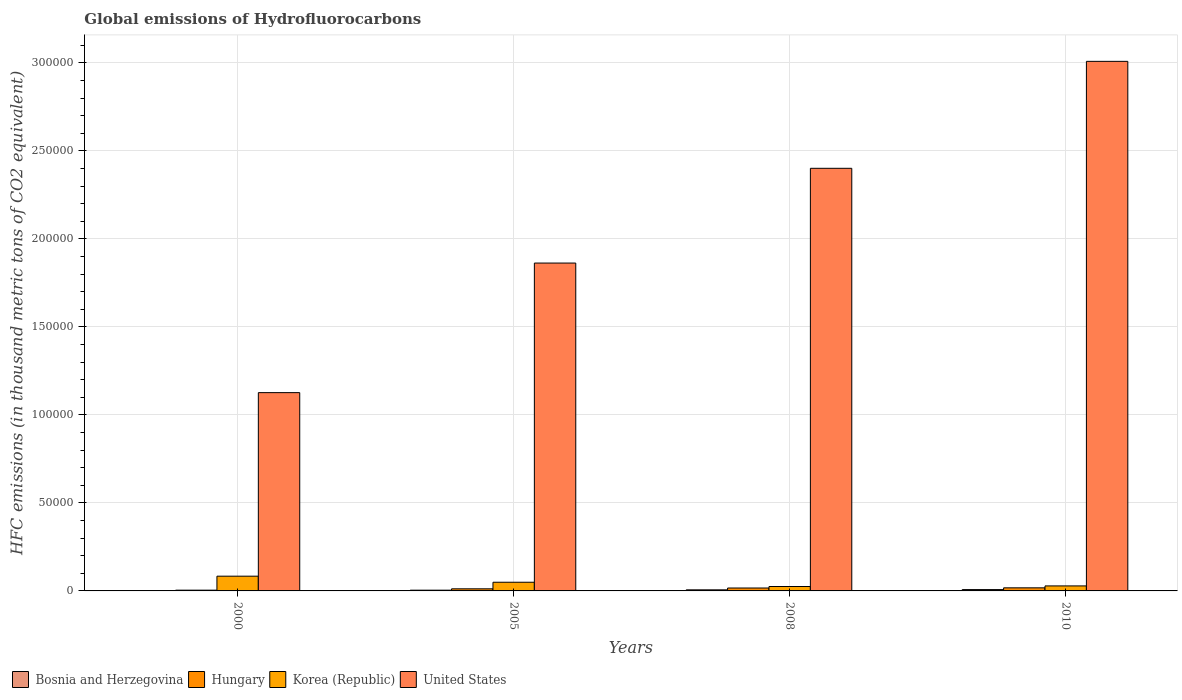How many different coloured bars are there?
Give a very brief answer. 4. Are the number of bars per tick equal to the number of legend labels?
Ensure brevity in your answer.  Yes. Are the number of bars on each tick of the X-axis equal?
Offer a terse response. Yes. How many bars are there on the 2nd tick from the left?
Your response must be concise. 4. What is the label of the 2nd group of bars from the left?
Your answer should be compact. 2005. What is the global emissions of Hydrofluorocarbons in United States in 2008?
Give a very brief answer. 2.40e+05. Across all years, what is the maximum global emissions of Hydrofluorocarbons in Korea (Republic)?
Make the answer very short. 8371.9. Across all years, what is the minimum global emissions of Hydrofluorocarbons in Korea (Republic)?
Offer a very short reply. 2511.2. In which year was the global emissions of Hydrofluorocarbons in Bosnia and Herzegovina maximum?
Keep it short and to the point. 2010. In which year was the global emissions of Hydrofluorocarbons in Korea (Republic) minimum?
Your answer should be very brief. 2008. What is the total global emissions of Hydrofluorocarbons in Korea (Republic) in the graph?
Ensure brevity in your answer.  1.87e+04. What is the difference between the global emissions of Hydrofluorocarbons in Bosnia and Herzegovina in 2005 and that in 2010?
Ensure brevity in your answer.  -332.5. What is the difference between the global emissions of Hydrofluorocarbons in Bosnia and Herzegovina in 2008 and the global emissions of Hydrofluorocarbons in Hungary in 2010?
Offer a terse response. -1131.4. What is the average global emissions of Hydrofluorocarbons in United States per year?
Make the answer very short. 2.10e+05. In the year 2010, what is the difference between the global emissions of Hydrofluorocarbons in Bosnia and Herzegovina and global emissions of Hydrofluorocarbons in Korea (Republic)?
Your answer should be very brief. -2089. What is the ratio of the global emissions of Hydrofluorocarbons in Korea (Republic) in 2005 to that in 2010?
Provide a short and direct response. 1.73. Is the difference between the global emissions of Hydrofluorocarbons in Bosnia and Herzegovina in 2005 and 2008 greater than the difference between the global emissions of Hydrofluorocarbons in Korea (Republic) in 2005 and 2008?
Make the answer very short. No. What is the difference between the highest and the second highest global emissions of Hydrofluorocarbons in Hungary?
Your answer should be very brief. 96.1. What is the difference between the highest and the lowest global emissions of Hydrofluorocarbons in Korea (Republic)?
Offer a very short reply. 5860.7. Is the sum of the global emissions of Hydrofluorocarbons in Korea (Republic) in 2005 and 2010 greater than the maximum global emissions of Hydrofluorocarbons in Bosnia and Herzegovina across all years?
Offer a very short reply. Yes. Is it the case that in every year, the sum of the global emissions of Hydrofluorocarbons in Bosnia and Herzegovina and global emissions of Hydrofluorocarbons in United States is greater than the sum of global emissions of Hydrofluorocarbons in Korea (Republic) and global emissions of Hydrofluorocarbons in Hungary?
Provide a succinct answer. Yes. What does the 2nd bar from the left in 2000 represents?
Keep it short and to the point. Hungary. What does the 3rd bar from the right in 2005 represents?
Your response must be concise. Hungary. Is it the case that in every year, the sum of the global emissions of Hydrofluorocarbons in Hungary and global emissions of Hydrofluorocarbons in Korea (Republic) is greater than the global emissions of Hydrofluorocarbons in Bosnia and Herzegovina?
Make the answer very short. Yes. What is the difference between two consecutive major ticks on the Y-axis?
Ensure brevity in your answer.  5.00e+04. Are the values on the major ticks of Y-axis written in scientific E-notation?
Your answer should be compact. No. Does the graph contain any zero values?
Ensure brevity in your answer.  No. Does the graph contain grids?
Offer a very short reply. Yes. What is the title of the graph?
Offer a very short reply. Global emissions of Hydrofluorocarbons. Does "Upper middle income" appear as one of the legend labels in the graph?
Make the answer very short. No. What is the label or title of the X-axis?
Your response must be concise. Years. What is the label or title of the Y-axis?
Your answer should be compact. HFC emissions (in thousand metric tons of CO2 equivalent). What is the HFC emissions (in thousand metric tons of CO2 equivalent) in Bosnia and Herzegovina in 2000?
Offer a very short reply. 79.8. What is the HFC emissions (in thousand metric tons of CO2 equivalent) of Hungary in 2000?
Provide a succinct answer. 428.2. What is the HFC emissions (in thousand metric tons of CO2 equivalent) in Korea (Republic) in 2000?
Your answer should be compact. 8371.9. What is the HFC emissions (in thousand metric tons of CO2 equivalent) in United States in 2000?
Provide a succinct answer. 1.13e+05. What is the HFC emissions (in thousand metric tons of CO2 equivalent) in Bosnia and Herzegovina in 2005?
Provide a succinct answer. 422.5. What is the HFC emissions (in thousand metric tons of CO2 equivalent) in Hungary in 2005?
Provide a succinct answer. 1191.4. What is the HFC emissions (in thousand metric tons of CO2 equivalent) in Korea (Republic) in 2005?
Your answer should be very brief. 4933.9. What is the HFC emissions (in thousand metric tons of CO2 equivalent) in United States in 2005?
Your answer should be very brief. 1.86e+05. What is the HFC emissions (in thousand metric tons of CO2 equivalent) of Bosnia and Herzegovina in 2008?
Your answer should be very brief. 617.6. What is the HFC emissions (in thousand metric tons of CO2 equivalent) of Hungary in 2008?
Give a very brief answer. 1652.9. What is the HFC emissions (in thousand metric tons of CO2 equivalent) of Korea (Republic) in 2008?
Provide a short and direct response. 2511.2. What is the HFC emissions (in thousand metric tons of CO2 equivalent) in United States in 2008?
Provide a short and direct response. 2.40e+05. What is the HFC emissions (in thousand metric tons of CO2 equivalent) of Bosnia and Herzegovina in 2010?
Your response must be concise. 755. What is the HFC emissions (in thousand metric tons of CO2 equivalent) of Hungary in 2010?
Your answer should be compact. 1749. What is the HFC emissions (in thousand metric tons of CO2 equivalent) in Korea (Republic) in 2010?
Your response must be concise. 2844. What is the HFC emissions (in thousand metric tons of CO2 equivalent) of United States in 2010?
Offer a terse response. 3.01e+05. Across all years, what is the maximum HFC emissions (in thousand metric tons of CO2 equivalent) of Bosnia and Herzegovina?
Provide a succinct answer. 755. Across all years, what is the maximum HFC emissions (in thousand metric tons of CO2 equivalent) of Hungary?
Offer a very short reply. 1749. Across all years, what is the maximum HFC emissions (in thousand metric tons of CO2 equivalent) in Korea (Republic)?
Make the answer very short. 8371.9. Across all years, what is the maximum HFC emissions (in thousand metric tons of CO2 equivalent) in United States?
Offer a very short reply. 3.01e+05. Across all years, what is the minimum HFC emissions (in thousand metric tons of CO2 equivalent) of Bosnia and Herzegovina?
Provide a short and direct response. 79.8. Across all years, what is the minimum HFC emissions (in thousand metric tons of CO2 equivalent) in Hungary?
Provide a succinct answer. 428.2. Across all years, what is the minimum HFC emissions (in thousand metric tons of CO2 equivalent) of Korea (Republic)?
Ensure brevity in your answer.  2511.2. Across all years, what is the minimum HFC emissions (in thousand metric tons of CO2 equivalent) in United States?
Offer a terse response. 1.13e+05. What is the total HFC emissions (in thousand metric tons of CO2 equivalent) of Bosnia and Herzegovina in the graph?
Give a very brief answer. 1874.9. What is the total HFC emissions (in thousand metric tons of CO2 equivalent) of Hungary in the graph?
Provide a short and direct response. 5021.5. What is the total HFC emissions (in thousand metric tons of CO2 equivalent) in Korea (Republic) in the graph?
Offer a terse response. 1.87e+04. What is the total HFC emissions (in thousand metric tons of CO2 equivalent) of United States in the graph?
Provide a succinct answer. 8.40e+05. What is the difference between the HFC emissions (in thousand metric tons of CO2 equivalent) of Bosnia and Herzegovina in 2000 and that in 2005?
Keep it short and to the point. -342.7. What is the difference between the HFC emissions (in thousand metric tons of CO2 equivalent) in Hungary in 2000 and that in 2005?
Your response must be concise. -763.2. What is the difference between the HFC emissions (in thousand metric tons of CO2 equivalent) of Korea (Republic) in 2000 and that in 2005?
Make the answer very short. 3438. What is the difference between the HFC emissions (in thousand metric tons of CO2 equivalent) in United States in 2000 and that in 2005?
Ensure brevity in your answer.  -7.36e+04. What is the difference between the HFC emissions (in thousand metric tons of CO2 equivalent) of Bosnia and Herzegovina in 2000 and that in 2008?
Provide a short and direct response. -537.8. What is the difference between the HFC emissions (in thousand metric tons of CO2 equivalent) in Hungary in 2000 and that in 2008?
Provide a short and direct response. -1224.7. What is the difference between the HFC emissions (in thousand metric tons of CO2 equivalent) of Korea (Republic) in 2000 and that in 2008?
Keep it short and to the point. 5860.7. What is the difference between the HFC emissions (in thousand metric tons of CO2 equivalent) in United States in 2000 and that in 2008?
Give a very brief answer. -1.27e+05. What is the difference between the HFC emissions (in thousand metric tons of CO2 equivalent) of Bosnia and Herzegovina in 2000 and that in 2010?
Your answer should be compact. -675.2. What is the difference between the HFC emissions (in thousand metric tons of CO2 equivalent) of Hungary in 2000 and that in 2010?
Offer a very short reply. -1320.8. What is the difference between the HFC emissions (in thousand metric tons of CO2 equivalent) of Korea (Republic) in 2000 and that in 2010?
Ensure brevity in your answer.  5527.9. What is the difference between the HFC emissions (in thousand metric tons of CO2 equivalent) of United States in 2000 and that in 2010?
Offer a very short reply. -1.88e+05. What is the difference between the HFC emissions (in thousand metric tons of CO2 equivalent) in Bosnia and Herzegovina in 2005 and that in 2008?
Provide a succinct answer. -195.1. What is the difference between the HFC emissions (in thousand metric tons of CO2 equivalent) in Hungary in 2005 and that in 2008?
Offer a very short reply. -461.5. What is the difference between the HFC emissions (in thousand metric tons of CO2 equivalent) of Korea (Republic) in 2005 and that in 2008?
Provide a succinct answer. 2422.7. What is the difference between the HFC emissions (in thousand metric tons of CO2 equivalent) of United States in 2005 and that in 2008?
Give a very brief answer. -5.38e+04. What is the difference between the HFC emissions (in thousand metric tons of CO2 equivalent) in Bosnia and Herzegovina in 2005 and that in 2010?
Provide a short and direct response. -332.5. What is the difference between the HFC emissions (in thousand metric tons of CO2 equivalent) in Hungary in 2005 and that in 2010?
Your answer should be very brief. -557.6. What is the difference between the HFC emissions (in thousand metric tons of CO2 equivalent) of Korea (Republic) in 2005 and that in 2010?
Provide a succinct answer. 2089.9. What is the difference between the HFC emissions (in thousand metric tons of CO2 equivalent) of United States in 2005 and that in 2010?
Provide a succinct answer. -1.15e+05. What is the difference between the HFC emissions (in thousand metric tons of CO2 equivalent) in Bosnia and Herzegovina in 2008 and that in 2010?
Offer a very short reply. -137.4. What is the difference between the HFC emissions (in thousand metric tons of CO2 equivalent) of Hungary in 2008 and that in 2010?
Your answer should be very brief. -96.1. What is the difference between the HFC emissions (in thousand metric tons of CO2 equivalent) of Korea (Republic) in 2008 and that in 2010?
Your answer should be very brief. -332.8. What is the difference between the HFC emissions (in thousand metric tons of CO2 equivalent) in United States in 2008 and that in 2010?
Your response must be concise. -6.08e+04. What is the difference between the HFC emissions (in thousand metric tons of CO2 equivalent) in Bosnia and Herzegovina in 2000 and the HFC emissions (in thousand metric tons of CO2 equivalent) in Hungary in 2005?
Offer a terse response. -1111.6. What is the difference between the HFC emissions (in thousand metric tons of CO2 equivalent) of Bosnia and Herzegovina in 2000 and the HFC emissions (in thousand metric tons of CO2 equivalent) of Korea (Republic) in 2005?
Provide a short and direct response. -4854.1. What is the difference between the HFC emissions (in thousand metric tons of CO2 equivalent) in Bosnia and Herzegovina in 2000 and the HFC emissions (in thousand metric tons of CO2 equivalent) in United States in 2005?
Your answer should be compact. -1.86e+05. What is the difference between the HFC emissions (in thousand metric tons of CO2 equivalent) of Hungary in 2000 and the HFC emissions (in thousand metric tons of CO2 equivalent) of Korea (Republic) in 2005?
Provide a short and direct response. -4505.7. What is the difference between the HFC emissions (in thousand metric tons of CO2 equivalent) of Hungary in 2000 and the HFC emissions (in thousand metric tons of CO2 equivalent) of United States in 2005?
Ensure brevity in your answer.  -1.86e+05. What is the difference between the HFC emissions (in thousand metric tons of CO2 equivalent) in Korea (Republic) in 2000 and the HFC emissions (in thousand metric tons of CO2 equivalent) in United States in 2005?
Ensure brevity in your answer.  -1.78e+05. What is the difference between the HFC emissions (in thousand metric tons of CO2 equivalent) of Bosnia and Herzegovina in 2000 and the HFC emissions (in thousand metric tons of CO2 equivalent) of Hungary in 2008?
Ensure brevity in your answer.  -1573.1. What is the difference between the HFC emissions (in thousand metric tons of CO2 equivalent) in Bosnia and Herzegovina in 2000 and the HFC emissions (in thousand metric tons of CO2 equivalent) in Korea (Republic) in 2008?
Your answer should be compact. -2431.4. What is the difference between the HFC emissions (in thousand metric tons of CO2 equivalent) in Bosnia and Herzegovina in 2000 and the HFC emissions (in thousand metric tons of CO2 equivalent) in United States in 2008?
Ensure brevity in your answer.  -2.40e+05. What is the difference between the HFC emissions (in thousand metric tons of CO2 equivalent) of Hungary in 2000 and the HFC emissions (in thousand metric tons of CO2 equivalent) of Korea (Republic) in 2008?
Give a very brief answer. -2083. What is the difference between the HFC emissions (in thousand metric tons of CO2 equivalent) of Hungary in 2000 and the HFC emissions (in thousand metric tons of CO2 equivalent) of United States in 2008?
Keep it short and to the point. -2.40e+05. What is the difference between the HFC emissions (in thousand metric tons of CO2 equivalent) of Korea (Republic) in 2000 and the HFC emissions (in thousand metric tons of CO2 equivalent) of United States in 2008?
Provide a succinct answer. -2.32e+05. What is the difference between the HFC emissions (in thousand metric tons of CO2 equivalent) in Bosnia and Herzegovina in 2000 and the HFC emissions (in thousand metric tons of CO2 equivalent) in Hungary in 2010?
Ensure brevity in your answer.  -1669.2. What is the difference between the HFC emissions (in thousand metric tons of CO2 equivalent) of Bosnia and Herzegovina in 2000 and the HFC emissions (in thousand metric tons of CO2 equivalent) of Korea (Republic) in 2010?
Provide a short and direct response. -2764.2. What is the difference between the HFC emissions (in thousand metric tons of CO2 equivalent) in Bosnia and Herzegovina in 2000 and the HFC emissions (in thousand metric tons of CO2 equivalent) in United States in 2010?
Ensure brevity in your answer.  -3.01e+05. What is the difference between the HFC emissions (in thousand metric tons of CO2 equivalent) of Hungary in 2000 and the HFC emissions (in thousand metric tons of CO2 equivalent) of Korea (Republic) in 2010?
Offer a terse response. -2415.8. What is the difference between the HFC emissions (in thousand metric tons of CO2 equivalent) of Hungary in 2000 and the HFC emissions (in thousand metric tons of CO2 equivalent) of United States in 2010?
Provide a short and direct response. -3.00e+05. What is the difference between the HFC emissions (in thousand metric tons of CO2 equivalent) in Korea (Republic) in 2000 and the HFC emissions (in thousand metric tons of CO2 equivalent) in United States in 2010?
Offer a very short reply. -2.93e+05. What is the difference between the HFC emissions (in thousand metric tons of CO2 equivalent) of Bosnia and Herzegovina in 2005 and the HFC emissions (in thousand metric tons of CO2 equivalent) of Hungary in 2008?
Your response must be concise. -1230.4. What is the difference between the HFC emissions (in thousand metric tons of CO2 equivalent) of Bosnia and Herzegovina in 2005 and the HFC emissions (in thousand metric tons of CO2 equivalent) of Korea (Republic) in 2008?
Offer a very short reply. -2088.7. What is the difference between the HFC emissions (in thousand metric tons of CO2 equivalent) in Bosnia and Herzegovina in 2005 and the HFC emissions (in thousand metric tons of CO2 equivalent) in United States in 2008?
Offer a very short reply. -2.40e+05. What is the difference between the HFC emissions (in thousand metric tons of CO2 equivalent) in Hungary in 2005 and the HFC emissions (in thousand metric tons of CO2 equivalent) in Korea (Republic) in 2008?
Give a very brief answer. -1319.8. What is the difference between the HFC emissions (in thousand metric tons of CO2 equivalent) of Hungary in 2005 and the HFC emissions (in thousand metric tons of CO2 equivalent) of United States in 2008?
Give a very brief answer. -2.39e+05. What is the difference between the HFC emissions (in thousand metric tons of CO2 equivalent) of Korea (Republic) in 2005 and the HFC emissions (in thousand metric tons of CO2 equivalent) of United States in 2008?
Offer a very short reply. -2.35e+05. What is the difference between the HFC emissions (in thousand metric tons of CO2 equivalent) of Bosnia and Herzegovina in 2005 and the HFC emissions (in thousand metric tons of CO2 equivalent) of Hungary in 2010?
Ensure brevity in your answer.  -1326.5. What is the difference between the HFC emissions (in thousand metric tons of CO2 equivalent) of Bosnia and Herzegovina in 2005 and the HFC emissions (in thousand metric tons of CO2 equivalent) of Korea (Republic) in 2010?
Offer a very short reply. -2421.5. What is the difference between the HFC emissions (in thousand metric tons of CO2 equivalent) in Bosnia and Herzegovina in 2005 and the HFC emissions (in thousand metric tons of CO2 equivalent) in United States in 2010?
Provide a succinct answer. -3.00e+05. What is the difference between the HFC emissions (in thousand metric tons of CO2 equivalent) in Hungary in 2005 and the HFC emissions (in thousand metric tons of CO2 equivalent) in Korea (Republic) in 2010?
Your answer should be compact. -1652.6. What is the difference between the HFC emissions (in thousand metric tons of CO2 equivalent) in Hungary in 2005 and the HFC emissions (in thousand metric tons of CO2 equivalent) in United States in 2010?
Offer a terse response. -3.00e+05. What is the difference between the HFC emissions (in thousand metric tons of CO2 equivalent) of Korea (Republic) in 2005 and the HFC emissions (in thousand metric tons of CO2 equivalent) of United States in 2010?
Offer a very short reply. -2.96e+05. What is the difference between the HFC emissions (in thousand metric tons of CO2 equivalent) of Bosnia and Herzegovina in 2008 and the HFC emissions (in thousand metric tons of CO2 equivalent) of Hungary in 2010?
Provide a succinct answer. -1131.4. What is the difference between the HFC emissions (in thousand metric tons of CO2 equivalent) of Bosnia and Herzegovina in 2008 and the HFC emissions (in thousand metric tons of CO2 equivalent) of Korea (Republic) in 2010?
Provide a short and direct response. -2226.4. What is the difference between the HFC emissions (in thousand metric tons of CO2 equivalent) in Bosnia and Herzegovina in 2008 and the HFC emissions (in thousand metric tons of CO2 equivalent) in United States in 2010?
Make the answer very short. -3.00e+05. What is the difference between the HFC emissions (in thousand metric tons of CO2 equivalent) of Hungary in 2008 and the HFC emissions (in thousand metric tons of CO2 equivalent) of Korea (Republic) in 2010?
Your answer should be compact. -1191.1. What is the difference between the HFC emissions (in thousand metric tons of CO2 equivalent) in Hungary in 2008 and the HFC emissions (in thousand metric tons of CO2 equivalent) in United States in 2010?
Provide a short and direct response. -2.99e+05. What is the difference between the HFC emissions (in thousand metric tons of CO2 equivalent) in Korea (Republic) in 2008 and the HFC emissions (in thousand metric tons of CO2 equivalent) in United States in 2010?
Make the answer very short. -2.98e+05. What is the average HFC emissions (in thousand metric tons of CO2 equivalent) in Bosnia and Herzegovina per year?
Your answer should be compact. 468.73. What is the average HFC emissions (in thousand metric tons of CO2 equivalent) of Hungary per year?
Your answer should be compact. 1255.38. What is the average HFC emissions (in thousand metric tons of CO2 equivalent) in Korea (Republic) per year?
Provide a succinct answer. 4665.25. What is the average HFC emissions (in thousand metric tons of CO2 equivalent) in United States per year?
Offer a very short reply. 2.10e+05. In the year 2000, what is the difference between the HFC emissions (in thousand metric tons of CO2 equivalent) in Bosnia and Herzegovina and HFC emissions (in thousand metric tons of CO2 equivalent) in Hungary?
Give a very brief answer. -348.4. In the year 2000, what is the difference between the HFC emissions (in thousand metric tons of CO2 equivalent) of Bosnia and Herzegovina and HFC emissions (in thousand metric tons of CO2 equivalent) of Korea (Republic)?
Give a very brief answer. -8292.1. In the year 2000, what is the difference between the HFC emissions (in thousand metric tons of CO2 equivalent) of Bosnia and Herzegovina and HFC emissions (in thousand metric tons of CO2 equivalent) of United States?
Make the answer very short. -1.13e+05. In the year 2000, what is the difference between the HFC emissions (in thousand metric tons of CO2 equivalent) in Hungary and HFC emissions (in thousand metric tons of CO2 equivalent) in Korea (Republic)?
Offer a very short reply. -7943.7. In the year 2000, what is the difference between the HFC emissions (in thousand metric tons of CO2 equivalent) of Hungary and HFC emissions (in thousand metric tons of CO2 equivalent) of United States?
Your answer should be compact. -1.12e+05. In the year 2000, what is the difference between the HFC emissions (in thousand metric tons of CO2 equivalent) of Korea (Republic) and HFC emissions (in thousand metric tons of CO2 equivalent) of United States?
Your response must be concise. -1.04e+05. In the year 2005, what is the difference between the HFC emissions (in thousand metric tons of CO2 equivalent) of Bosnia and Herzegovina and HFC emissions (in thousand metric tons of CO2 equivalent) of Hungary?
Offer a very short reply. -768.9. In the year 2005, what is the difference between the HFC emissions (in thousand metric tons of CO2 equivalent) in Bosnia and Herzegovina and HFC emissions (in thousand metric tons of CO2 equivalent) in Korea (Republic)?
Offer a very short reply. -4511.4. In the year 2005, what is the difference between the HFC emissions (in thousand metric tons of CO2 equivalent) in Bosnia and Herzegovina and HFC emissions (in thousand metric tons of CO2 equivalent) in United States?
Your answer should be compact. -1.86e+05. In the year 2005, what is the difference between the HFC emissions (in thousand metric tons of CO2 equivalent) in Hungary and HFC emissions (in thousand metric tons of CO2 equivalent) in Korea (Republic)?
Make the answer very short. -3742.5. In the year 2005, what is the difference between the HFC emissions (in thousand metric tons of CO2 equivalent) of Hungary and HFC emissions (in thousand metric tons of CO2 equivalent) of United States?
Provide a succinct answer. -1.85e+05. In the year 2005, what is the difference between the HFC emissions (in thousand metric tons of CO2 equivalent) of Korea (Republic) and HFC emissions (in thousand metric tons of CO2 equivalent) of United States?
Give a very brief answer. -1.81e+05. In the year 2008, what is the difference between the HFC emissions (in thousand metric tons of CO2 equivalent) of Bosnia and Herzegovina and HFC emissions (in thousand metric tons of CO2 equivalent) of Hungary?
Your answer should be compact. -1035.3. In the year 2008, what is the difference between the HFC emissions (in thousand metric tons of CO2 equivalent) in Bosnia and Herzegovina and HFC emissions (in thousand metric tons of CO2 equivalent) in Korea (Republic)?
Your answer should be very brief. -1893.6. In the year 2008, what is the difference between the HFC emissions (in thousand metric tons of CO2 equivalent) of Bosnia and Herzegovina and HFC emissions (in thousand metric tons of CO2 equivalent) of United States?
Your answer should be compact. -2.40e+05. In the year 2008, what is the difference between the HFC emissions (in thousand metric tons of CO2 equivalent) in Hungary and HFC emissions (in thousand metric tons of CO2 equivalent) in Korea (Republic)?
Your response must be concise. -858.3. In the year 2008, what is the difference between the HFC emissions (in thousand metric tons of CO2 equivalent) in Hungary and HFC emissions (in thousand metric tons of CO2 equivalent) in United States?
Give a very brief answer. -2.38e+05. In the year 2008, what is the difference between the HFC emissions (in thousand metric tons of CO2 equivalent) in Korea (Republic) and HFC emissions (in thousand metric tons of CO2 equivalent) in United States?
Your response must be concise. -2.38e+05. In the year 2010, what is the difference between the HFC emissions (in thousand metric tons of CO2 equivalent) of Bosnia and Herzegovina and HFC emissions (in thousand metric tons of CO2 equivalent) of Hungary?
Provide a short and direct response. -994. In the year 2010, what is the difference between the HFC emissions (in thousand metric tons of CO2 equivalent) in Bosnia and Herzegovina and HFC emissions (in thousand metric tons of CO2 equivalent) in Korea (Republic)?
Your answer should be very brief. -2089. In the year 2010, what is the difference between the HFC emissions (in thousand metric tons of CO2 equivalent) in Bosnia and Herzegovina and HFC emissions (in thousand metric tons of CO2 equivalent) in United States?
Ensure brevity in your answer.  -3.00e+05. In the year 2010, what is the difference between the HFC emissions (in thousand metric tons of CO2 equivalent) of Hungary and HFC emissions (in thousand metric tons of CO2 equivalent) of Korea (Republic)?
Offer a very short reply. -1095. In the year 2010, what is the difference between the HFC emissions (in thousand metric tons of CO2 equivalent) of Hungary and HFC emissions (in thousand metric tons of CO2 equivalent) of United States?
Make the answer very short. -2.99e+05. In the year 2010, what is the difference between the HFC emissions (in thousand metric tons of CO2 equivalent) of Korea (Republic) and HFC emissions (in thousand metric tons of CO2 equivalent) of United States?
Provide a short and direct response. -2.98e+05. What is the ratio of the HFC emissions (in thousand metric tons of CO2 equivalent) in Bosnia and Herzegovina in 2000 to that in 2005?
Your answer should be compact. 0.19. What is the ratio of the HFC emissions (in thousand metric tons of CO2 equivalent) in Hungary in 2000 to that in 2005?
Provide a succinct answer. 0.36. What is the ratio of the HFC emissions (in thousand metric tons of CO2 equivalent) in Korea (Republic) in 2000 to that in 2005?
Give a very brief answer. 1.7. What is the ratio of the HFC emissions (in thousand metric tons of CO2 equivalent) of United States in 2000 to that in 2005?
Your answer should be very brief. 0.6. What is the ratio of the HFC emissions (in thousand metric tons of CO2 equivalent) of Bosnia and Herzegovina in 2000 to that in 2008?
Provide a succinct answer. 0.13. What is the ratio of the HFC emissions (in thousand metric tons of CO2 equivalent) in Hungary in 2000 to that in 2008?
Your answer should be compact. 0.26. What is the ratio of the HFC emissions (in thousand metric tons of CO2 equivalent) of Korea (Republic) in 2000 to that in 2008?
Offer a terse response. 3.33. What is the ratio of the HFC emissions (in thousand metric tons of CO2 equivalent) of United States in 2000 to that in 2008?
Offer a terse response. 0.47. What is the ratio of the HFC emissions (in thousand metric tons of CO2 equivalent) in Bosnia and Herzegovina in 2000 to that in 2010?
Offer a terse response. 0.11. What is the ratio of the HFC emissions (in thousand metric tons of CO2 equivalent) of Hungary in 2000 to that in 2010?
Your answer should be very brief. 0.24. What is the ratio of the HFC emissions (in thousand metric tons of CO2 equivalent) in Korea (Republic) in 2000 to that in 2010?
Offer a terse response. 2.94. What is the ratio of the HFC emissions (in thousand metric tons of CO2 equivalent) of United States in 2000 to that in 2010?
Offer a terse response. 0.37. What is the ratio of the HFC emissions (in thousand metric tons of CO2 equivalent) of Bosnia and Herzegovina in 2005 to that in 2008?
Make the answer very short. 0.68. What is the ratio of the HFC emissions (in thousand metric tons of CO2 equivalent) of Hungary in 2005 to that in 2008?
Provide a short and direct response. 0.72. What is the ratio of the HFC emissions (in thousand metric tons of CO2 equivalent) of Korea (Republic) in 2005 to that in 2008?
Keep it short and to the point. 1.96. What is the ratio of the HFC emissions (in thousand metric tons of CO2 equivalent) of United States in 2005 to that in 2008?
Your answer should be compact. 0.78. What is the ratio of the HFC emissions (in thousand metric tons of CO2 equivalent) of Bosnia and Herzegovina in 2005 to that in 2010?
Make the answer very short. 0.56. What is the ratio of the HFC emissions (in thousand metric tons of CO2 equivalent) of Hungary in 2005 to that in 2010?
Provide a short and direct response. 0.68. What is the ratio of the HFC emissions (in thousand metric tons of CO2 equivalent) of Korea (Republic) in 2005 to that in 2010?
Make the answer very short. 1.73. What is the ratio of the HFC emissions (in thousand metric tons of CO2 equivalent) of United States in 2005 to that in 2010?
Your response must be concise. 0.62. What is the ratio of the HFC emissions (in thousand metric tons of CO2 equivalent) of Bosnia and Herzegovina in 2008 to that in 2010?
Your answer should be compact. 0.82. What is the ratio of the HFC emissions (in thousand metric tons of CO2 equivalent) in Hungary in 2008 to that in 2010?
Keep it short and to the point. 0.95. What is the ratio of the HFC emissions (in thousand metric tons of CO2 equivalent) in Korea (Republic) in 2008 to that in 2010?
Make the answer very short. 0.88. What is the ratio of the HFC emissions (in thousand metric tons of CO2 equivalent) of United States in 2008 to that in 2010?
Your answer should be very brief. 0.8. What is the difference between the highest and the second highest HFC emissions (in thousand metric tons of CO2 equivalent) of Bosnia and Herzegovina?
Offer a very short reply. 137.4. What is the difference between the highest and the second highest HFC emissions (in thousand metric tons of CO2 equivalent) of Hungary?
Keep it short and to the point. 96.1. What is the difference between the highest and the second highest HFC emissions (in thousand metric tons of CO2 equivalent) of Korea (Republic)?
Make the answer very short. 3438. What is the difference between the highest and the second highest HFC emissions (in thousand metric tons of CO2 equivalent) in United States?
Your answer should be compact. 6.08e+04. What is the difference between the highest and the lowest HFC emissions (in thousand metric tons of CO2 equivalent) of Bosnia and Herzegovina?
Offer a terse response. 675.2. What is the difference between the highest and the lowest HFC emissions (in thousand metric tons of CO2 equivalent) in Hungary?
Your answer should be compact. 1320.8. What is the difference between the highest and the lowest HFC emissions (in thousand metric tons of CO2 equivalent) of Korea (Republic)?
Keep it short and to the point. 5860.7. What is the difference between the highest and the lowest HFC emissions (in thousand metric tons of CO2 equivalent) of United States?
Keep it short and to the point. 1.88e+05. 